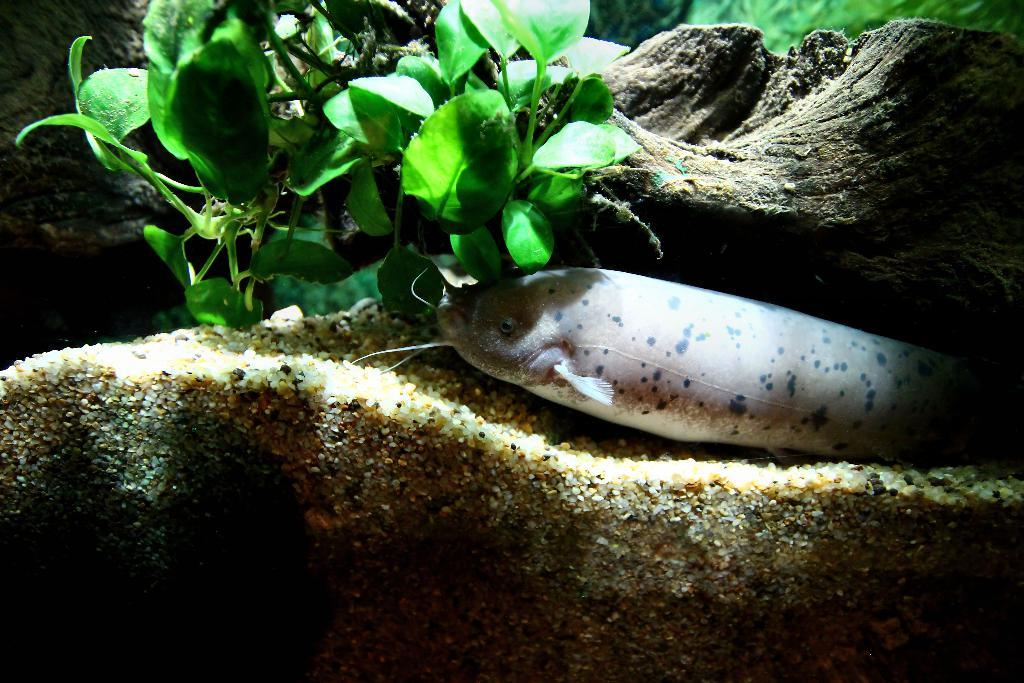What type of natural feature is present in the image? There is a water body in the image. What type of living organism can be seen in the image? There is a fish in the image. What type of plant is present in the image? There is a plant in the image. What type of worm can be seen crawling on the plant in the image? There is no worm present in the image; only a fish, a plant, and a water body are visible. 